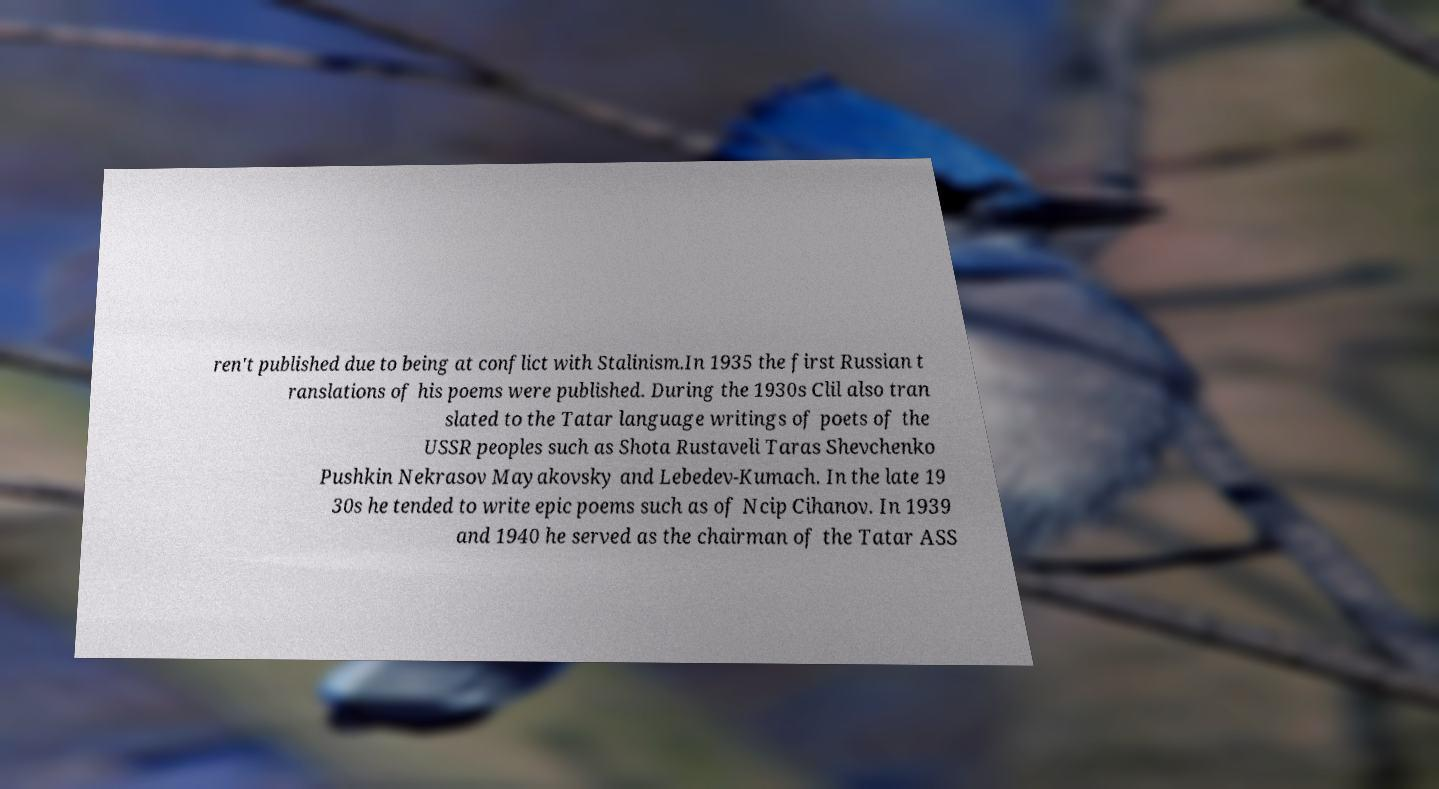Could you extract and type out the text from this image? ren't published due to being at conflict with Stalinism.In 1935 the first Russian t ranslations of his poems were published. During the 1930s Clil also tran slated to the Tatar language writings of poets of the USSR peoples such as Shota Rustaveli Taras Shevchenko Pushkin Nekrasov Mayakovsky and Lebedev-Kumach. In the late 19 30s he tended to write epic poems such as of Ncip Cihanov. In 1939 and 1940 he served as the chairman of the Tatar ASS 